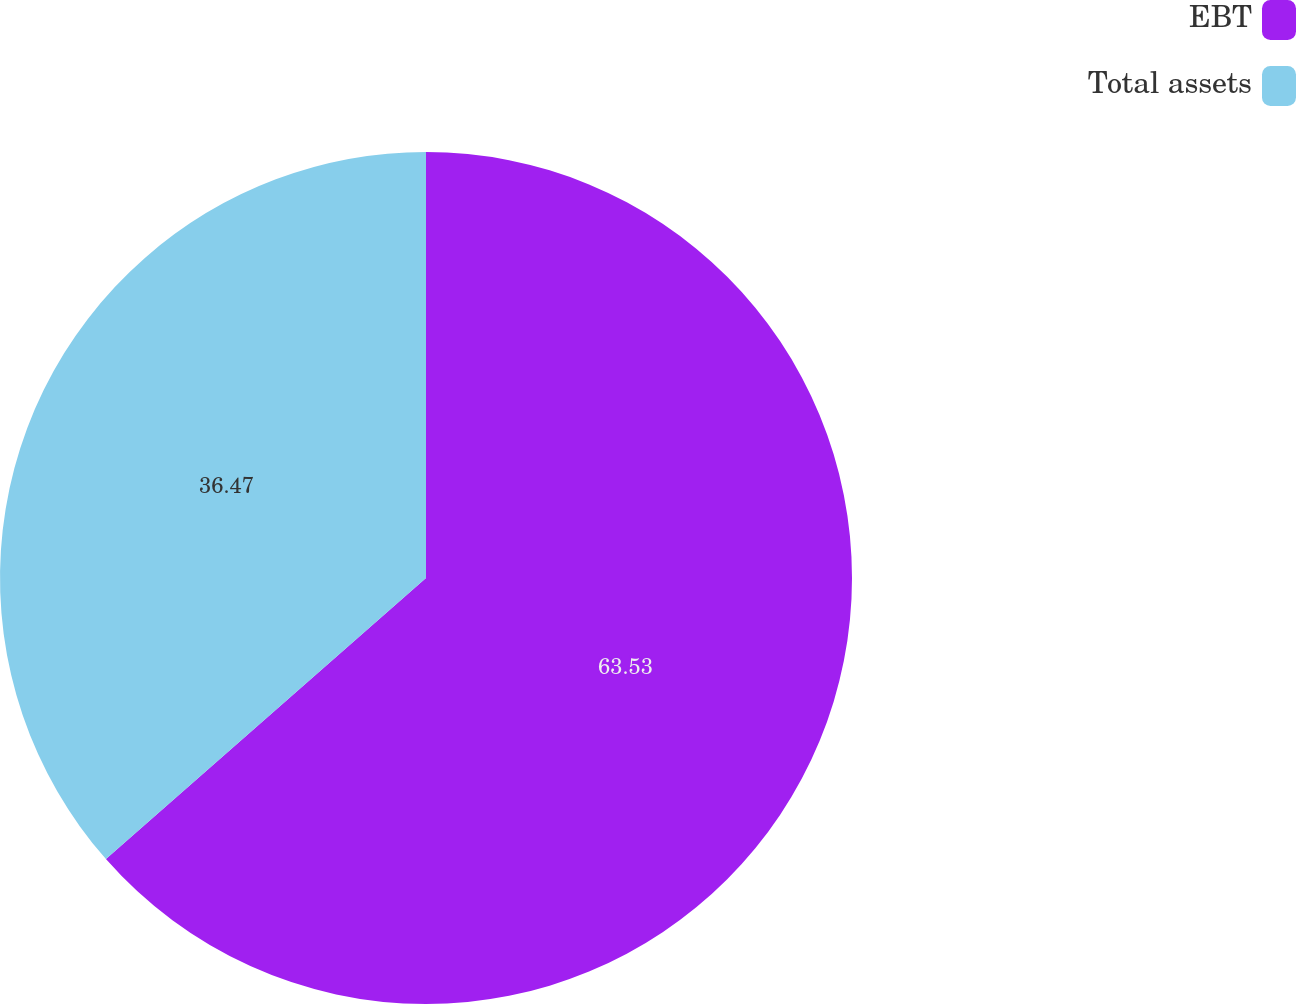Convert chart. <chart><loc_0><loc_0><loc_500><loc_500><pie_chart><fcel>EBT<fcel>Total assets<nl><fcel>63.53%<fcel>36.47%<nl></chart> 